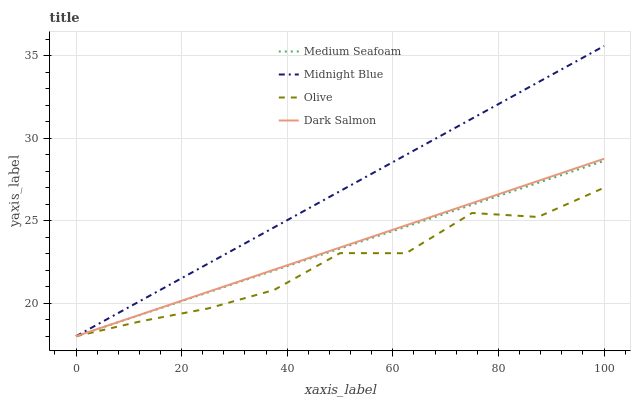Does Olive have the minimum area under the curve?
Answer yes or no. Yes. Does Midnight Blue have the maximum area under the curve?
Answer yes or no. Yes. Does Dark Salmon have the minimum area under the curve?
Answer yes or no. No. Does Dark Salmon have the maximum area under the curve?
Answer yes or no. No. Is Dark Salmon the smoothest?
Answer yes or no. Yes. Is Olive the roughest?
Answer yes or no. Yes. Is Medium Seafoam the smoothest?
Answer yes or no. No. Is Medium Seafoam the roughest?
Answer yes or no. No. Does Midnight Blue have the highest value?
Answer yes or no. Yes. Does Dark Salmon have the highest value?
Answer yes or no. No. Does Medium Seafoam intersect Dark Salmon?
Answer yes or no. Yes. Is Medium Seafoam less than Dark Salmon?
Answer yes or no. No. Is Medium Seafoam greater than Dark Salmon?
Answer yes or no. No. 